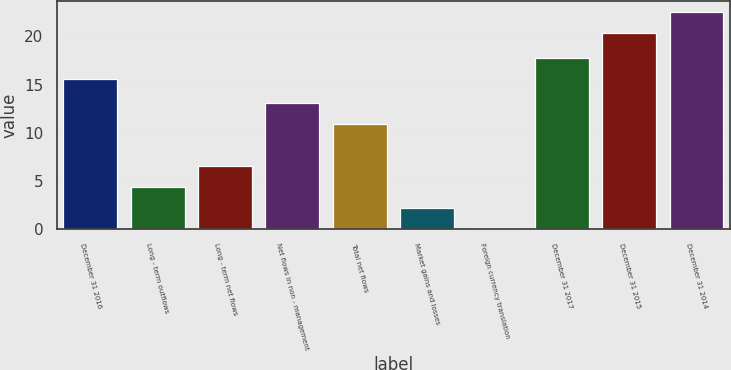Convert chart. <chart><loc_0><loc_0><loc_500><loc_500><bar_chart><fcel>December 31 2016<fcel>Long - term outflows<fcel>Long - term net flows<fcel>Net flows in non - management<fcel>Total net flows<fcel>Market gains and losses<fcel>Foreign currency translation<fcel>December 31 2017<fcel>December 31 2015<fcel>December 31 2014<nl><fcel>15.6<fcel>4.42<fcel>6.58<fcel>13.06<fcel>10.9<fcel>2.26<fcel>0.1<fcel>17.76<fcel>20.4<fcel>22.56<nl></chart> 